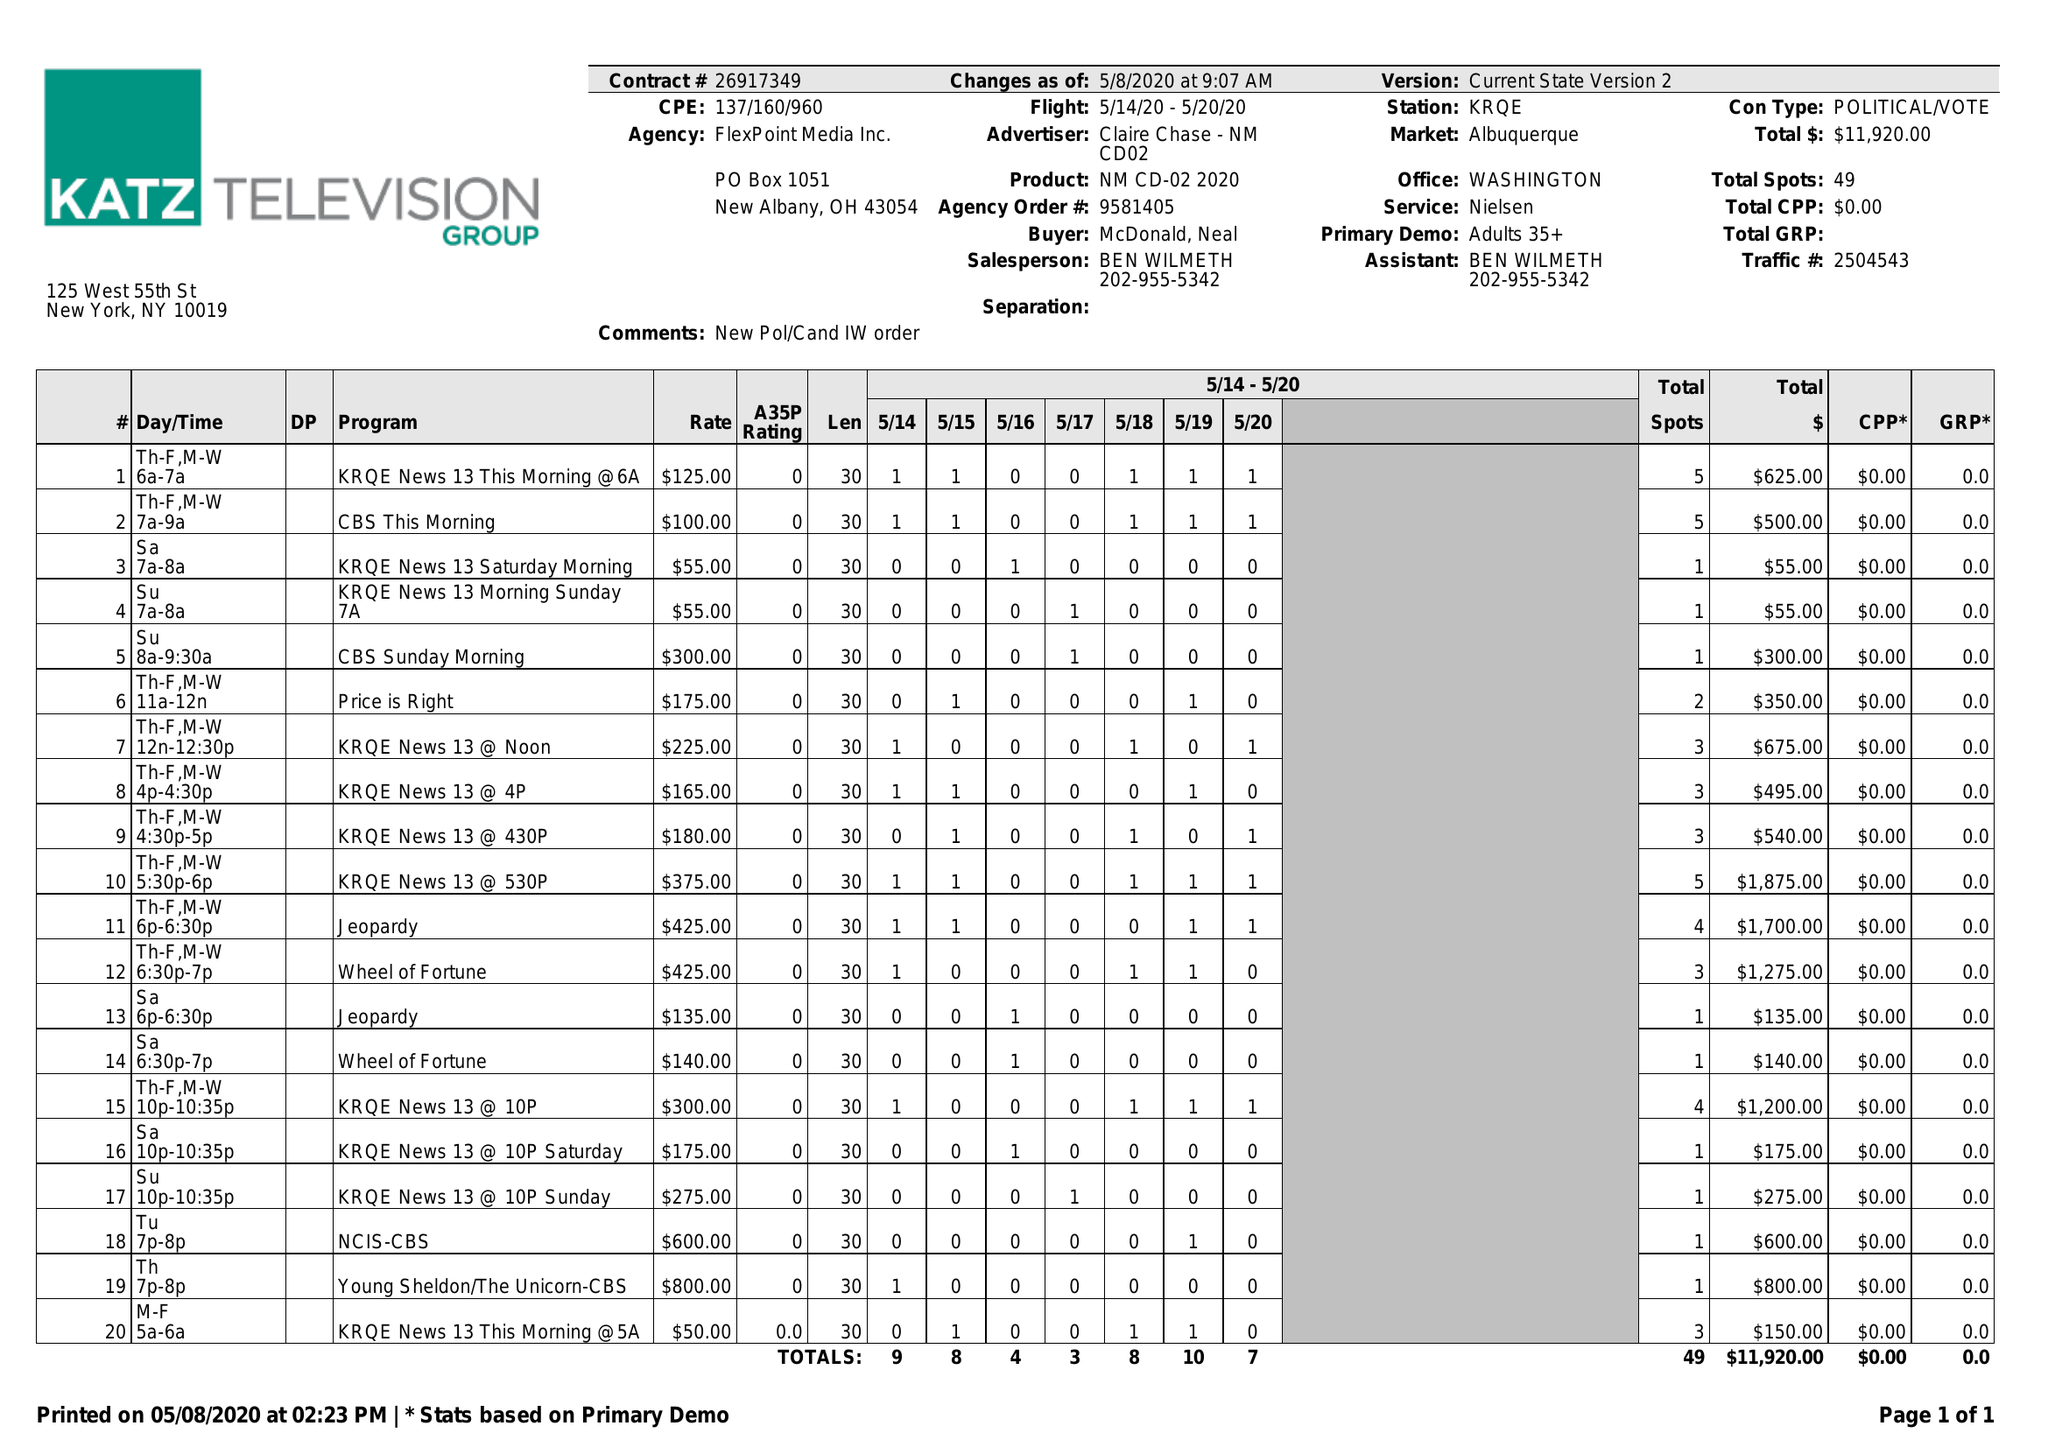What is the value for the gross_amount?
Answer the question using a single word or phrase. 11920.00 